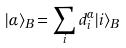<formula> <loc_0><loc_0><loc_500><loc_500>| \alpha \rangle _ { B } = \sum _ { i } d ^ { \alpha } _ { i } | i \rangle _ { B }</formula> 